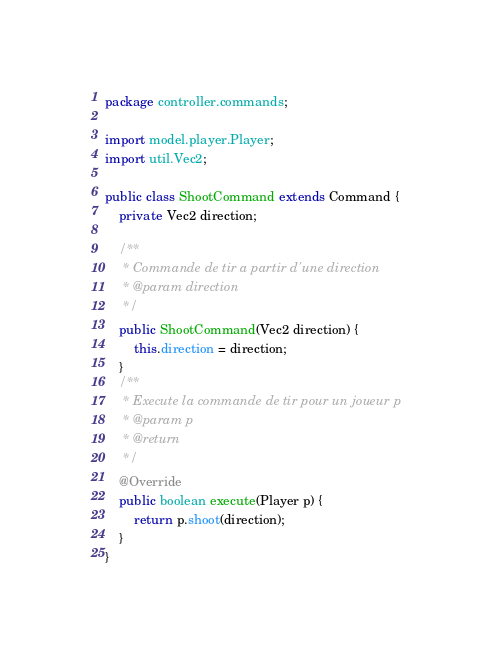Convert code to text. <code><loc_0><loc_0><loc_500><loc_500><_Java_>package controller.commands;

import model.player.Player;
import util.Vec2;

public class ShootCommand extends Command {
    private Vec2 direction;

    /**
     * Commande de tir a partir d'une direction
     * @param direction 
     */
    public ShootCommand(Vec2 direction) {
        this.direction = direction;
    }
    /**
     * Execute la commande de tir pour un joueur p
     * @param p
     * @return 
     */
    @Override
    public boolean execute(Player p) {
        return p.shoot(direction);
    }
}
</code> 